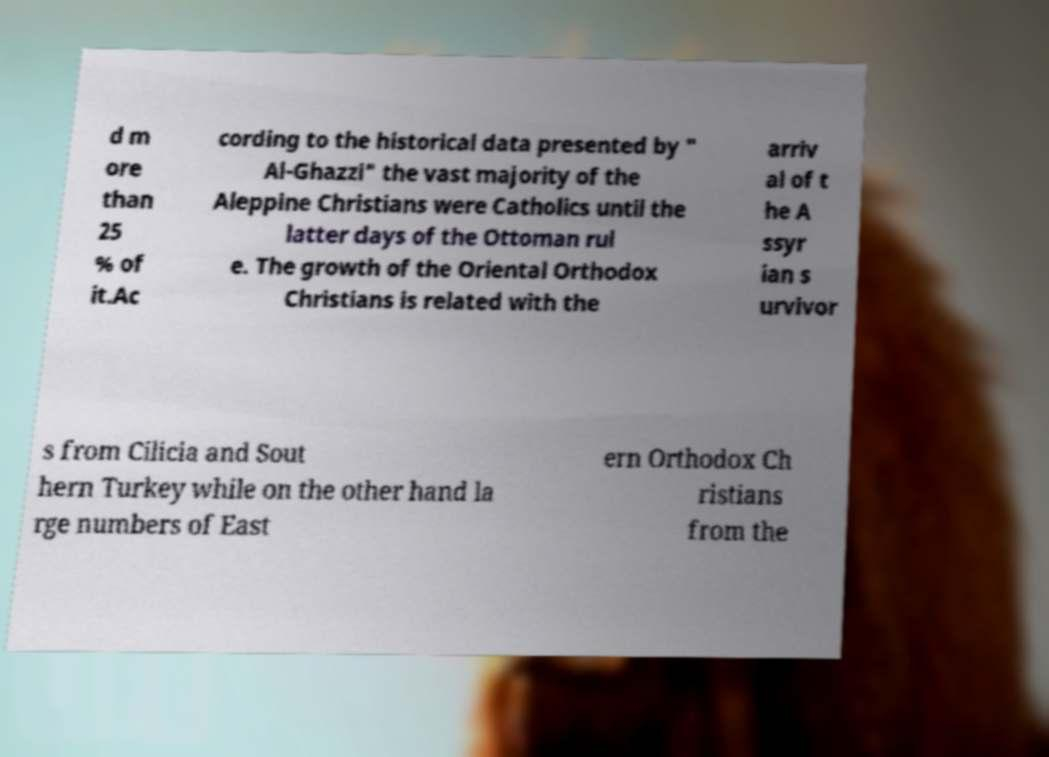What messages or text are displayed in this image? I need them in a readable, typed format. d m ore than 25 % of it.Ac cording to the historical data presented by " Al-Ghazzi" the vast majority of the Aleppine Christians were Catholics until the latter days of the Ottoman rul e. The growth of the Oriental Orthodox Christians is related with the arriv al of t he A ssyr ian s urvivor s from Cilicia and Sout hern Turkey while on the other hand la rge numbers of East ern Orthodox Ch ristians from the 